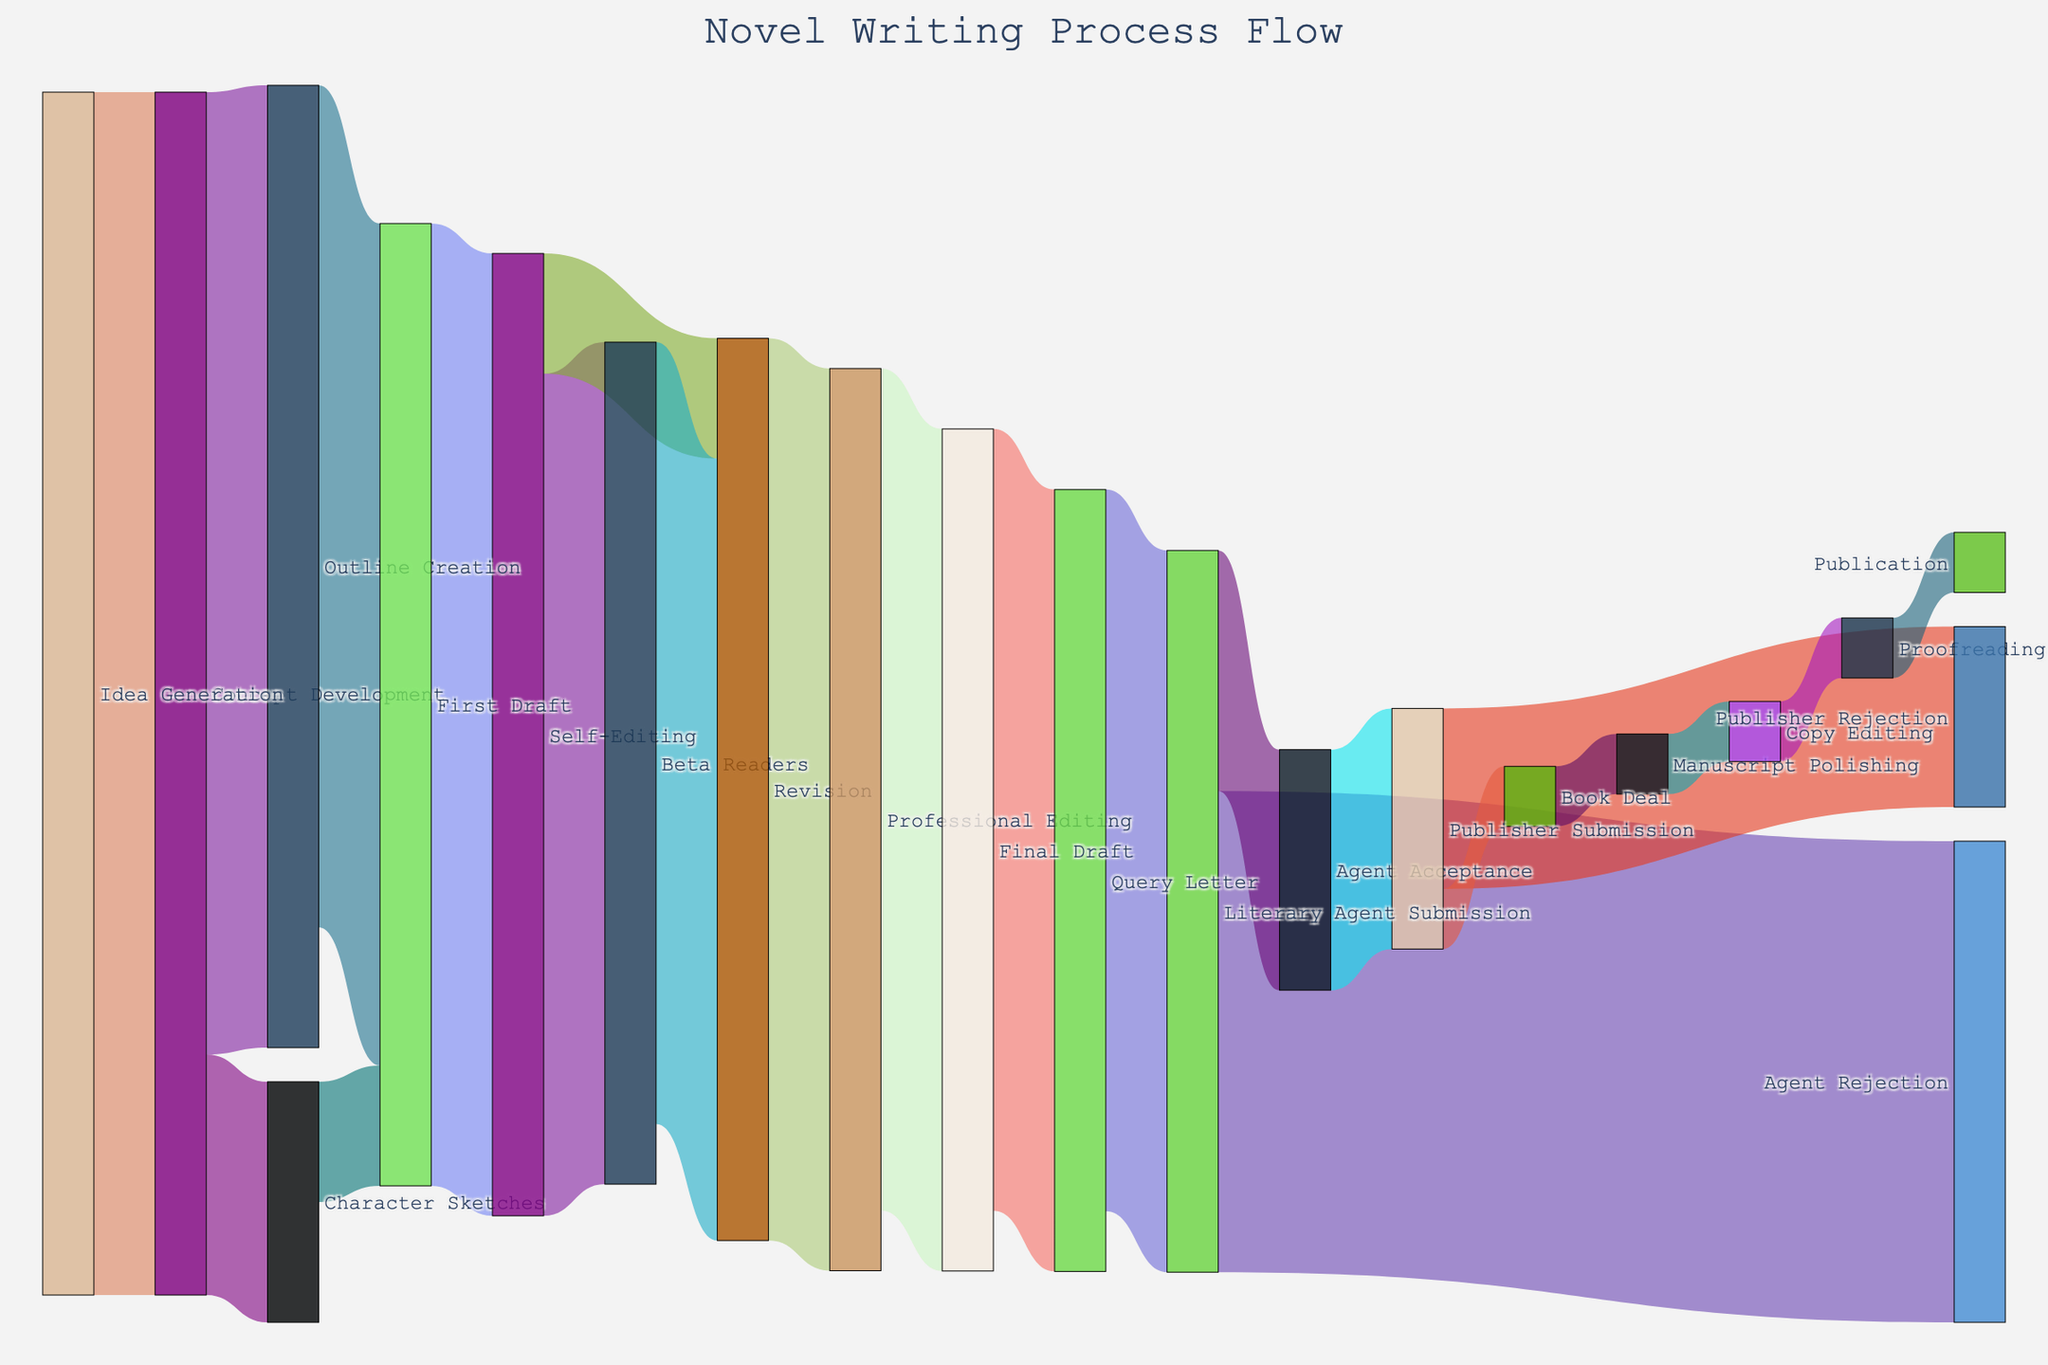What is the title of the diagram? The title of the diagram is usually displayed prominently at the top of the figure. In this case, it reads "Novel Writing Process Flow."
Answer: Novel Writing Process Flow How many stages are involved from Idea Generation to Publication? To find the number of stages, count each unique node from the starting point (Idea Generation) to the endpoint (Publication). The nodes are: Idea Generation, Concept Development, Outline Creation, Character Sketches, First Draft, Self-Editing, Beta Readers, Revision, Professional Editing, Final Draft, Query Letter, Literary Agent Submission, Agent Rejection, Agent Acceptance, Publisher Submission, Publisher Rejection, Book Deal, Manuscript Polishing, Copy Editing, Proofreading, and Publication.
Answer: 21 What is the final value output at the Publication stage? Follow the flow from the initial Idea Generation stage to the final Publication stage, tracing the linked values. From Manuscript Polishing to Publication, it retains 5 units of value as it passes through Copy Editing and Proofreading.
Answer: 5 Which stage receives the highest number of inputs? Look for the node with the most arrows pointing towards it. First Draft has inputs from both Outline Creation and Character Sketches, making it the stage with the highest number of inputs.
Answer: First Draft What is the minimum number of major stages a manuscript goes through before reaching publication? Trace the shortest path from Idea Generation to Publication, ensuring each stage significantly changes the manuscript. The path is: Idea Generation -> Concept Development -> Outline Creation -> First Draft -> Self-Editing -> Beta Readers -> Revision -> Professional Editing -> Final Draft -> Query Letter -> Literary Agent Submission -> Agent Acceptance -> Publisher Submission -> Book Deal -> Manuscript Polishing -> Copy Editing -> Proofreading -> Publication.
Answer: 17 What percentage of manuscripts make it from Literary Agent Submission to Publisher Submission? From Literary Agent Submission, 20 manuscripts move to Agent Acceptance. To find the percentage relative to the 60 that are submitted: (20/60) * 100%.
Answer: 33.33% Which stage directly precedes the final draft? Identify the node connected to the Final Draft stage. Professional Editing is the stage immediately before Final Draft.
Answer: Professional Editing How many units are rejected by publishers after submission? Identify the value corresponding to the flow from Publisher Submission to Publisher Rejection. The value is 15 units.
Answer: 15 units Compare the number of units that go into Self-Editing versus those going into Revision from Self-Editing. Which one is higher and by how much? Self-Editing sends 70 units to Beta Readers and 10 units to Revision. The total output is 80 units. Beta Readers send 65 to Revision, making 75 total units going into Revision (10 from Self-Editing + 65 from Beta Readers). Compare 80 units to 75 units.
Answer: Self-Editing is higher by 5 units 